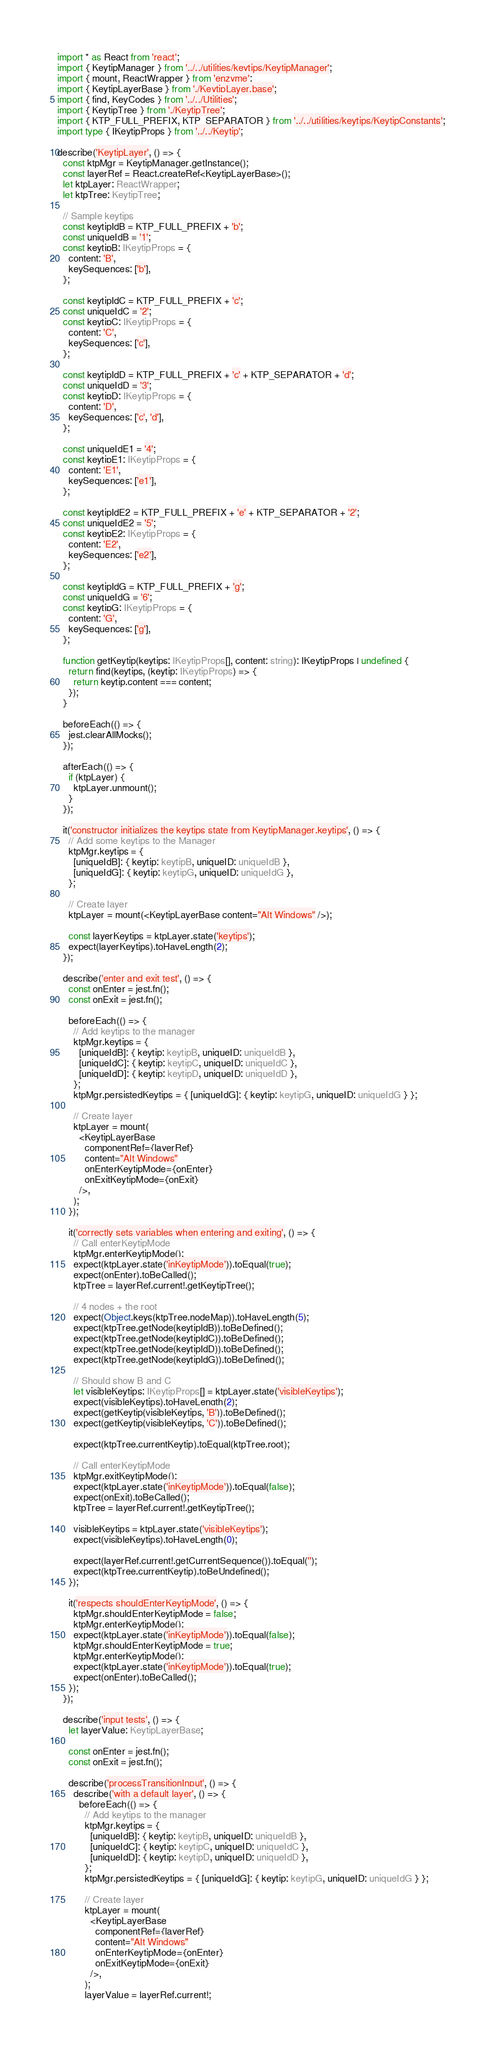<code> <loc_0><loc_0><loc_500><loc_500><_TypeScript_>import * as React from 'react';
import { KeytipManager } from '../../utilities/keytips/KeytipManager';
import { mount, ReactWrapper } from 'enzyme';
import { KeytipLayerBase } from './KeytipLayer.base';
import { find, KeyCodes } from '../../Utilities';
import { KeytipTree } from './KeytipTree';
import { KTP_FULL_PREFIX, KTP_SEPARATOR } from '../../utilities/keytips/KeytipConstants';
import type { IKeytipProps } from '../../Keytip';

describe('KeytipLayer', () => {
  const ktpMgr = KeytipManager.getInstance();
  const layerRef = React.createRef<KeytipLayerBase>();
  let ktpLayer: ReactWrapper;
  let ktpTree: KeytipTree;

  // Sample keytips
  const keytipIdB = KTP_FULL_PREFIX + 'b';
  const uniqueIdB = '1';
  const keytipB: IKeytipProps = {
    content: 'B',
    keySequences: ['b'],
  };

  const keytipIdC = KTP_FULL_PREFIX + 'c';
  const uniqueIdC = '2';
  const keytipC: IKeytipProps = {
    content: 'C',
    keySequences: ['c'],
  };

  const keytipIdD = KTP_FULL_PREFIX + 'c' + KTP_SEPARATOR + 'd';
  const uniqueIdD = '3';
  const keytipD: IKeytipProps = {
    content: 'D',
    keySequences: ['c', 'd'],
  };

  const uniqueIdE1 = '4';
  const keytipE1: IKeytipProps = {
    content: 'E1',
    keySequences: ['e1'],
  };

  const keytipIdE2 = KTP_FULL_PREFIX + 'e' + KTP_SEPARATOR + '2';
  const uniqueIdE2 = '5';
  const keytipE2: IKeytipProps = {
    content: 'E2',
    keySequences: ['e2'],
  };

  const keytipIdG = KTP_FULL_PREFIX + 'g';
  const uniqueIdG = '6';
  const keytipG: IKeytipProps = {
    content: 'G',
    keySequences: ['g'],
  };

  function getKeytip(keytips: IKeytipProps[], content: string): IKeytipProps | undefined {
    return find(keytips, (keytip: IKeytipProps) => {
      return keytip.content === content;
    });
  }

  beforeEach(() => {
    jest.clearAllMocks();
  });

  afterEach(() => {
    if (ktpLayer) {
      ktpLayer.unmount();
    }
  });

  it('constructor initializes the keytips state from KeytipManager.keytips', () => {
    // Add some keytips to the Manager
    ktpMgr.keytips = {
      [uniqueIdB]: { keytip: keytipB, uniqueID: uniqueIdB },
      [uniqueIdG]: { keytip: keytipG, uniqueID: uniqueIdG },
    };

    // Create layer
    ktpLayer = mount(<KeytipLayerBase content="Alt Windows" />);

    const layerKeytips = ktpLayer.state('keytips');
    expect(layerKeytips).toHaveLength(2);
  });

  describe('enter and exit test', () => {
    const onEnter = jest.fn();
    const onExit = jest.fn();

    beforeEach(() => {
      // Add keytips to the manager
      ktpMgr.keytips = {
        [uniqueIdB]: { keytip: keytipB, uniqueID: uniqueIdB },
        [uniqueIdC]: { keytip: keytipC, uniqueID: uniqueIdC },
        [uniqueIdD]: { keytip: keytipD, uniqueID: uniqueIdD },
      };
      ktpMgr.persistedKeytips = { [uniqueIdG]: { keytip: keytipG, uniqueID: uniqueIdG } };

      // Create layer
      ktpLayer = mount(
        <KeytipLayerBase
          componentRef={layerRef}
          content="Alt Windows"
          onEnterKeytipMode={onEnter}
          onExitKeytipMode={onExit}
        />,
      );
    });

    it('correctly sets variables when entering and exiting', () => {
      // Call enterKeytipMode
      ktpMgr.enterKeytipMode();
      expect(ktpLayer.state('inKeytipMode')).toEqual(true);
      expect(onEnter).toBeCalled();
      ktpTree = layerRef.current!.getKeytipTree();

      // 4 nodes + the root
      expect(Object.keys(ktpTree.nodeMap)).toHaveLength(5);
      expect(ktpTree.getNode(keytipIdB)).toBeDefined();
      expect(ktpTree.getNode(keytipIdC)).toBeDefined();
      expect(ktpTree.getNode(keytipIdD)).toBeDefined();
      expect(ktpTree.getNode(keytipIdG)).toBeDefined();

      // Should show B and C
      let visibleKeytips: IKeytipProps[] = ktpLayer.state('visibleKeytips');
      expect(visibleKeytips).toHaveLength(2);
      expect(getKeytip(visibleKeytips, 'B')).toBeDefined();
      expect(getKeytip(visibleKeytips, 'C')).toBeDefined();

      expect(ktpTree.currentKeytip).toEqual(ktpTree.root);

      // Call enterKeytipMode
      ktpMgr.exitKeytipMode();
      expect(ktpLayer.state('inKeytipMode')).toEqual(false);
      expect(onExit).toBeCalled();
      ktpTree = layerRef.current!.getKeytipTree();

      visibleKeytips = ktpLayer.state('visibleKeytips');
      expect(visibleKeytips).toHaveLength(0);

      expect(layerRef.current!.getCurrentSequence()).toEqual('');
      expect(ktpTree.currentKeytip).toBeUndefined();
    });

    it('respects shouldEnterKeytipMode', () => {
      ktpMgr.shouldEnterKeytipMode = false;
      ktpMgr.enterKeytipMode();
      expect(ktpLayer.state('inKeytipMode')).toEqual(false);
      ktpMgr.shouldEnterKeytipMode = true;
      ktpMgr.enterKeytipMode();
      expect(ktpLayer.state('inKeytipMode')).toEqual(true);
      expect(onEnter).toBeCalled();
    });
  });

  describe('input tests', () => {
    let layerValue: KeytipLayerBase;

    const onEnter = jest.fn();
    const onExit = jest.fn();

    describe('processTransitionInput', () => {
      describe('with a default layer', () => {
        beforeEach(() => {
          // Add keytips to the manager
          ktpMgr.keytips = {
            [uniqueIdB]: { keytip: keytipB, uniqueID: uniqueIdB },
            [uniqueIdC]: { keytip: keytipC, uniqueID: uniqueIdC },
            [uniqueIdD]: { keytip: keytipD, uniqueID: uniqueIdD },
          };
          ktpMgr.persistedKeytips = { [uniqueIdG]: { keytip: keytipG, uniqueID: uniqueIdG } };

          // Create layer
          ktpLayer = mount(
            <KeytipLayerBase
              componentRef={layerRef}
              content="Alt Windows"
              onEnterKeytipMode={onEnter}
              onExitKeytipMode={onExit}
            />,
          );
          layerValue = layerRef.current!;</code> 